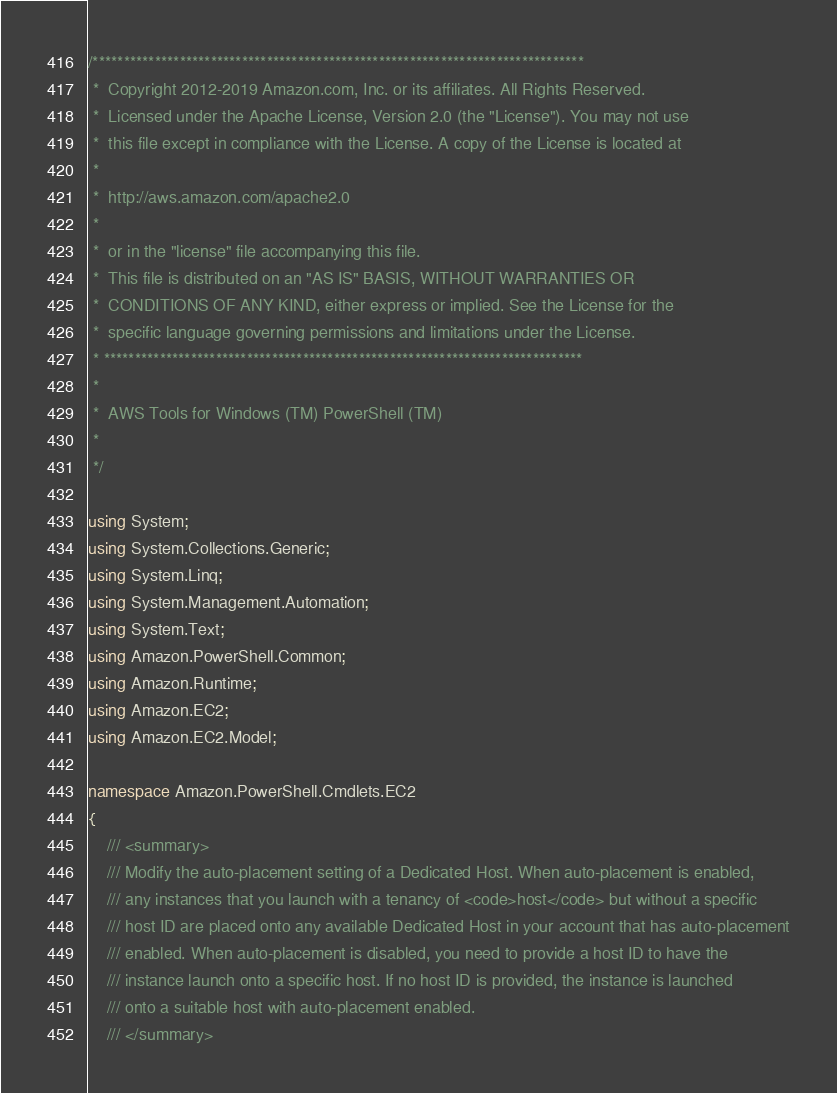Convert code to text. <code><loc_0><loc_0><loc_500><loc_500><_C#_>/*******************************************************************************
 *  Copyright 2012-2019 Amazon.com, Inc. or its affiliates. All Rights Reserved.
 *  Licensed under the Apache License, Version 2.0 (the "License"). You may not use
 *  this file except in compliance with the License. A copy of the License is located at
 *
 *  http://aws.amazon.com/apache2.0
 *
 *  or in the "license" file accompanying this file.
 *  This file is distributed on an "AS IS" BASIS, WITHOUT WARRANTIES OR
 *  CONDITIONS OF ANY KIND, either express or implied. See the License for the
 *  specific language governing permissions and limitations under the License.
 * *****************************************************************************
 *
 *  AWS Tools for Windows (TM) PowerShell (TM)
 *
 */

using System;
using System.Collections.Generic;
using System.Linq;
using System.Management.Automation;
using System.Text;
using Amazon.PowerShell.Common;
using Amazon.Runtime;
using Amazon.EC2;
using Amazon.EC2.Model;

namespace Amazon.PowerShell.Cmdlets.EC2
{
    /// <summary>
    /// Modify the auto-placement setting of a Dedicated Host. When auto-placement is enabled,
    /// any instances that you launch with a tenancy of <code>host</code> but without a specific
    /// host ID are placed onto any available Dedicated Host in your account that has auto-placement
    /// enabled. When auto-placement is disabled, you need to provide a host ID to have the
    /// instance launch onto a specific host. If no host ID is provided, the instance is launched
    /// onto a suitable host with auto-placement enabled.
    /// </summary></code> 